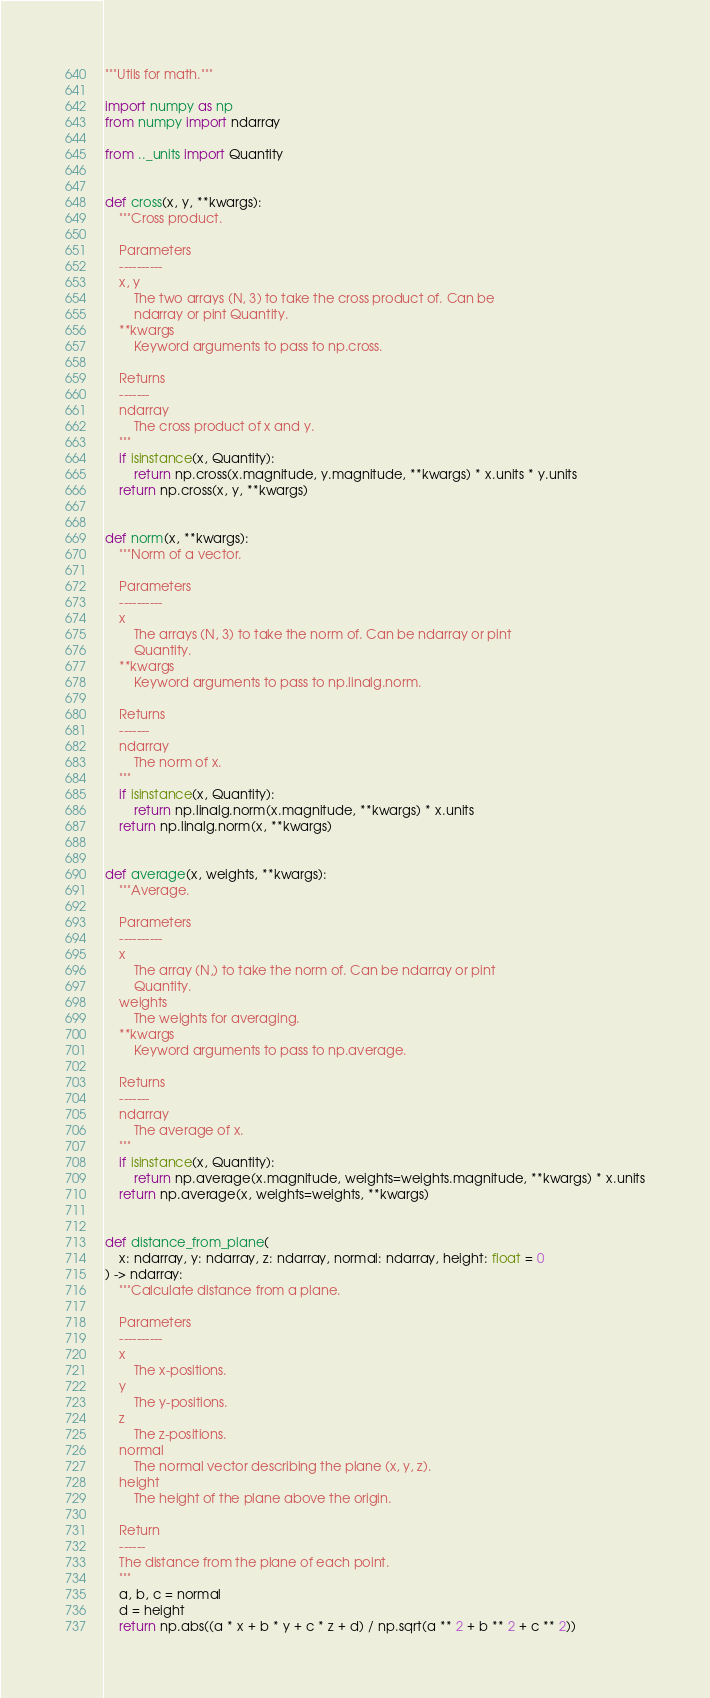Convert code to text. <code><loc_0><loc_0><loc_500><loc_500><_Python_>"""Utils for math."""

import numpy as np
from numpy import ndarray

from .._units import Quantity


def cross(x, y, **kwargs):
    """Cross product.

    Parameters
    ----------
    x, y
        The two arrays (N, 3) to take the cross product of. Can be
        ndarray or pint Quantity.
    **kwargs
        Keyword arguments to pass to np.cross.

    Returns
    -------
    ndarray
        The cross product of x and y.
    """
    if isinstance(x, Quantity):
        return np.cross(x.magnitude, y.magnitude, **kwargs) * x.units * y.units
    return np.cross(x, y, **kwargs)


def norm(x, **kwargs):
    """Norm of a vector.

    Parameters
    ----------
    x
        The arrays (N, 3) to take the norm of. Can be ndarray or pint
        Quantity.
    **kwargs
        Keyword arguments to pass to np.linalg.norm.

    Returns
    -------
    ndarray
        The norm of x.
    """
    if isinstance(x, Quantity):
        return np.linalg.norm(x.magnitude, **kwargs) * x.units
    return np.linalg.norm(x, **kwargs)


def average(x, weights, **kwargs):
    """Average.

    Parameters
    ----------
    x
        The array (N,) to take the norm of. Can be ndarray or pint
        Quantity.
    weights
        The weights for averaging.
    **kwargs
        Keyword arguments to pass to np.average.

    Returns
    -------
    ndarray
        The average of x.
    """
    if isinstance(x, Quantity):
        return np.average(x.magnitude, weights=weights.magnitude, **kwargs) * x.units
    return np.average(x, weights=weights, **kwargs)


def distance_from_plane(
    x: ndarray, y: ndarray, z: ndarray, normal: ndarray, height: float = 0
) -> ndarray:
    """Calculate distance from a plane.

    Parameters
    ----------
    x
        The x-positions.
    y
        The y-positions.
    z
        The z-positions.
    normal
        The normal vector describing the plane (x, y, z).
    height
        The height of the plane above the origin.

    Return
    ------
    The distance from the plane of each point.
    """
    a, b, c = normal
    d = height
    return np.abs((a * x + b * y + c * z + d) / np.sqrt(a ** 2 + b ** 2 + c ** 2))
</code> 